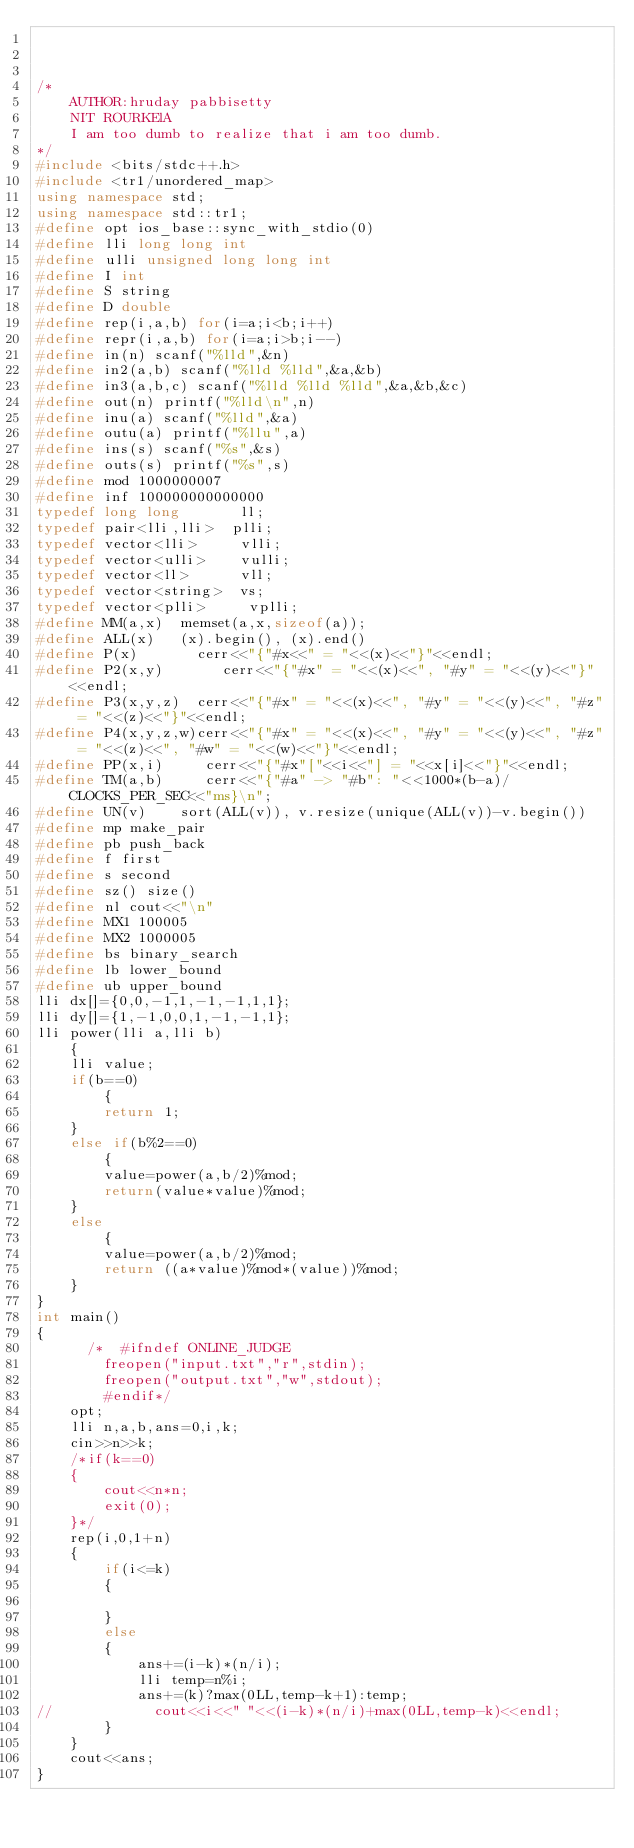<code> <loc_0><loc_0><loc_500><loc_500><_C++_>


/*
    AUTHOR:hruday pabbisetty
    NIT ROURKElA
    I am too dumb to realize that i am too dumb.
*/
#include <bits/stdc++.h>
#include <tr1/unordered_map>
using namespace std;
using namespace std::tr1;
#define opt ios_base::sync_with_stdio(0)
#define lli long long int
#define ulli unsigned long long int
#define I int
#define S string
#define D double
#define rep(i,a,b) for(i=a;i<b;i++)
#define repr(i,a,b) for(i=a;i>b;i--)
#define in(n) scanf("%lld",&n)
#define in2(a,b) scanf("%lld %lld",&a,&b)
#define in3(a,b,c) scanf("%lld %lld %lld",&a,&b,&c)
#define out(n) printf("%lld\n",n)
#define inu(a) scanf("%lld",&a)
#define outu(a) printf("%llu",a)
#define ins(s) scanf("%s",&s)
#define outs(s) printf("%s",s)
#define mod 1000000007
#define inf 100000000000000
typedef long long       ll;
typedef pair<lli,lli>  plli;
typedef vector<lli>     vlli;
typedef vector<ulli>    vulli;
typedef vector<ll>      vll;
typedef vector<string>  vs;
typedef vector<plli>     vplli;
#define MM(a,x)  memset(a,x,sizeof(a));
#define ALL(x)   (x).begin(), (x).end()
#define P(x)       cerr<<"{"#x<<" = "<<(x)<<"}"<<endl;
#define P2(x,y)       cerr<<"{"#x" = "<<(x)<<", "#y" = "<<(y)<<"}"<<endl;
#define P3(x,y,z)  cerr<<"{"#x" = "<<(x)<<", "#y" = "<<(y)<<", "#z" = "<<(z)<<"}"<<endl;
#define P4(x,y,z,w)cerr<<"{"#x" = "<<(x)<<", "#y" = "<<(y)<<", "#z" = "<<(z)<<", "#w" = "<<(w)<<"}"<<endl;
#define PP(x,i)     cerr<<"{"#x"["<<i<<"] = "<<x[i]<<"}"<<endl;
#define TM(a,b)     cerr<<"{"#a" -> "#b": "<<1000*(b-a)/CLOCKS_PER_SEC<<"ms}\n";
#define UN(v)    sort(ALL(v)), v.resize(unique(ALL(v))-v.begin())
#define mp make_pair
#define pb push_back
#define f first
#define s second
#define sz() size()
#define nl cout<<"\n"
#define MX1 100005
#define MX2 1000005
#define bs binary_search
#define lb lower_bound
#define ub upper_bound
lli dx[]={0,0,-1,1,-1,-1,1,1};
lli dy[]={1,-1,0,0,1,-1,-1,1};
lli power(lli a,lli b)
    {
    lli value;
    if(b==0)
        {
        return 1;
    }
    else if(b%2==0)
        {
        value=power(a,b/2)%mod;
        return(value*value)%mod;
    }
    else
        {
        value=power(a,b/2)%mod;
        return ((a*value)%mod*(value))%mod;
    }
}
int main()
{
      /*  #ifndef ONLINE_JUDGE
        freopen("input.txt","r",stdin);
        freopen("output.txt","w",stdout);
        #endif*/
    opt;
    lli n,a,b,ans=0,i,k;
    cin>>n>>k;
    /*if(k==0)
    {
        cout<<n*n;
        exit(0);
    }*/
    rep(i,0,1+n)
    {
        if(i<=k)
        {

        }
        else
        {
            ans+=(i-k)*(n/i);
            lli temp=n%i;
            ans+=(k)?max(0LL,temp-k+1):temp;
//            cout<<i<<" "<<(i-k)*(n/i)+max(0LL,temp-k)<<endl;
        }
    }
    cout<<ans;
}
</code> 